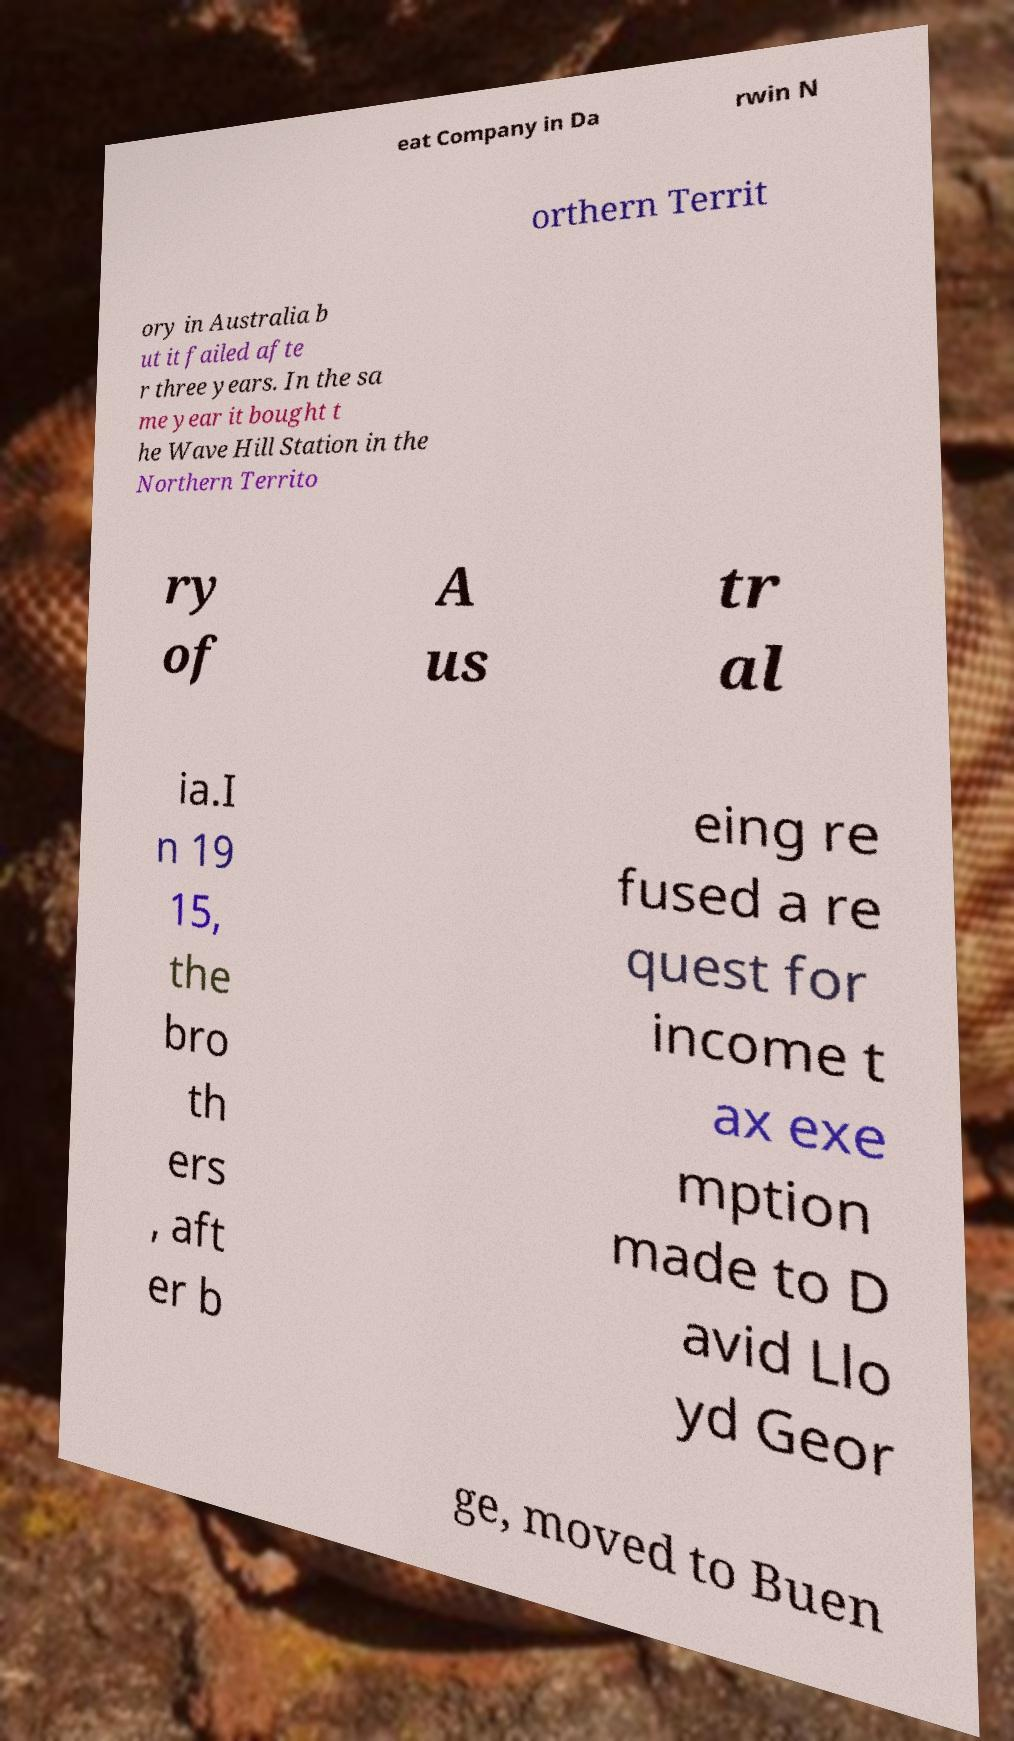Can you accurately transcribe the text from the provided image for me? eat Company in Da rwin N orthern Territ ory in Australia b ut it failed afte r three years. In the sa me year it bought t he Wave Hill Station in the Northern Territo ry of A us tr al ia.I n 19 15, the bro th ers , aft er b eing re fused a re quest for income t ax exe mption made to D avid Llo yd Geor ge, moved to Buen 